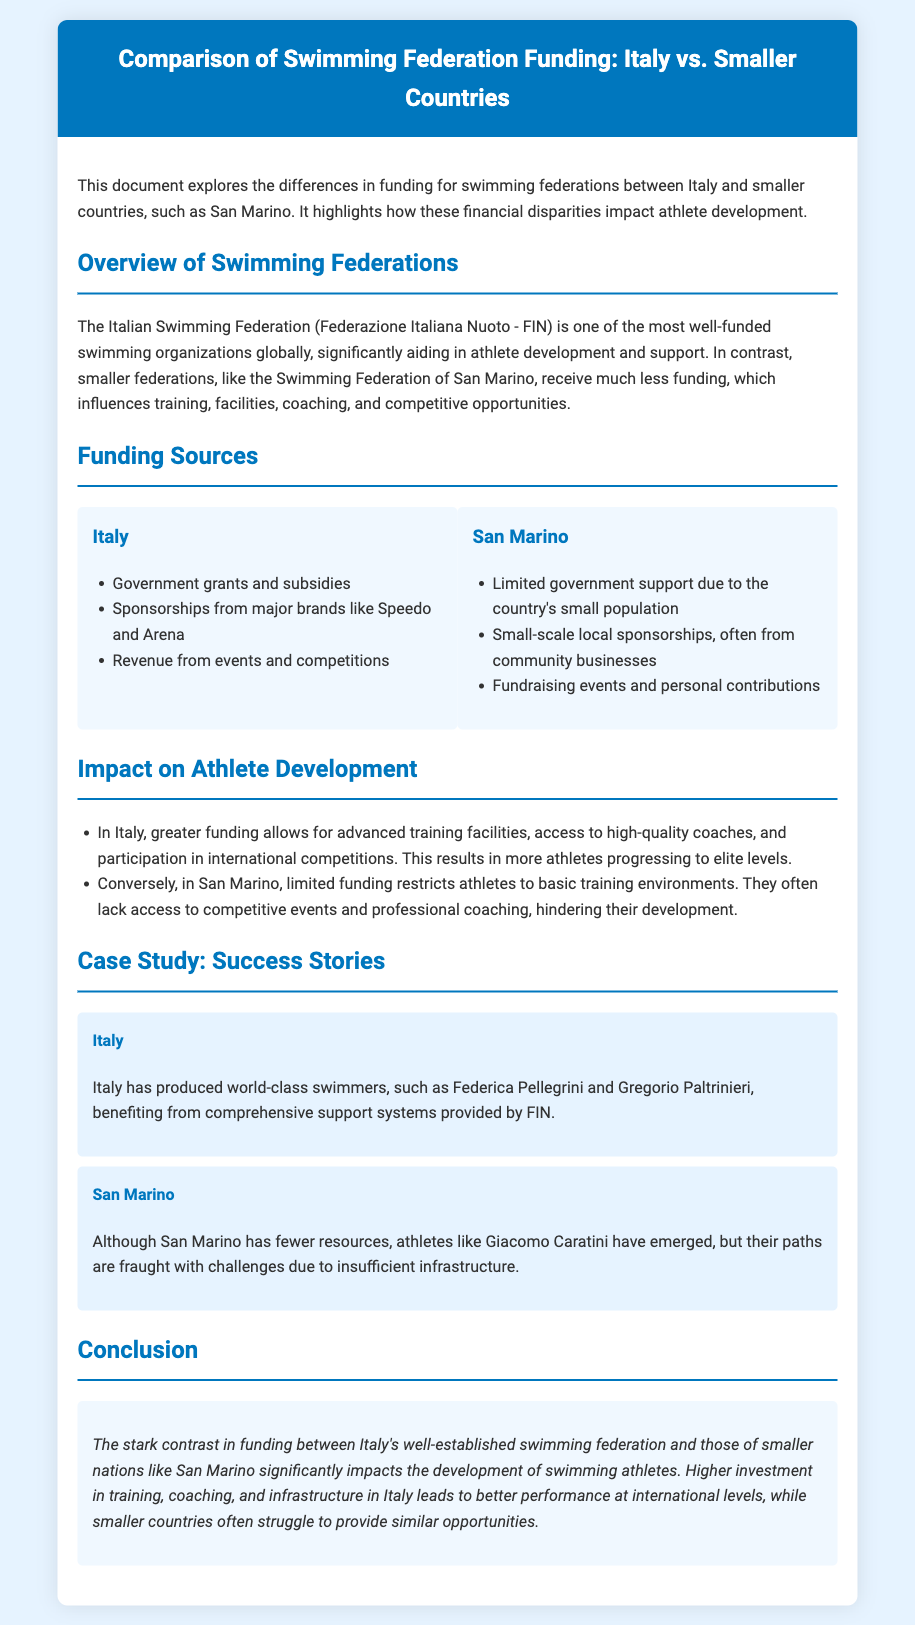What is the title of the document? The title is stated in the header of the document, emphasizing the comparison of funding between Italy and smaller countries.
Answer: Comparison of Swimming Federation Funding: Italy vs. Smaller Countries Who are the notable Italian swimmers mentioned? The document provides examples of successful Italian swimmers as a case study of athlete development in Italy.
Answer: Federica Pellegrini and Gregorio Paltrinieri What is one major source of funding for Italy's swimming federation? The list under Italy's funding sources highlights key financial support channels for their swimming organization.
Answer: Government grants and subsidies What challenge do San Marino athletes face due to limited funding? The document explains the impact of funding on athlete development in San Marino, describing specific challenges due to financial constraints.
Answer: Insufficient infrastructure Which two types of sponsorships does San Marino rely on? The funding sources section outlines the types of financial support available to San Marino's swimming federation, indicating the limited scale of these sponsorships.
Answer: Local sponsorships and fundraising events What is the main conclusion drawn in the document? The conclusion section summarizes the primary findings of the document regarding the impact of funding on athlete development across nations.
Answer: Higher investment in Italy leads to better performance at international levels 